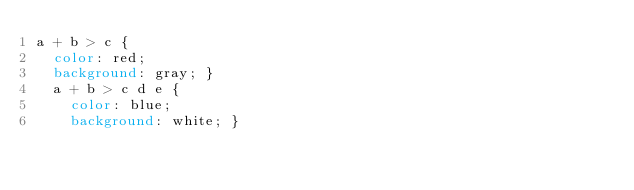<code> <loc_0><loc_0><loc_500><loc_500><_CSS_>a + b > c {
  color: red;
  background: gray; }
  a + b > c d e {
    color: blue;
    background: white; }
</code> 